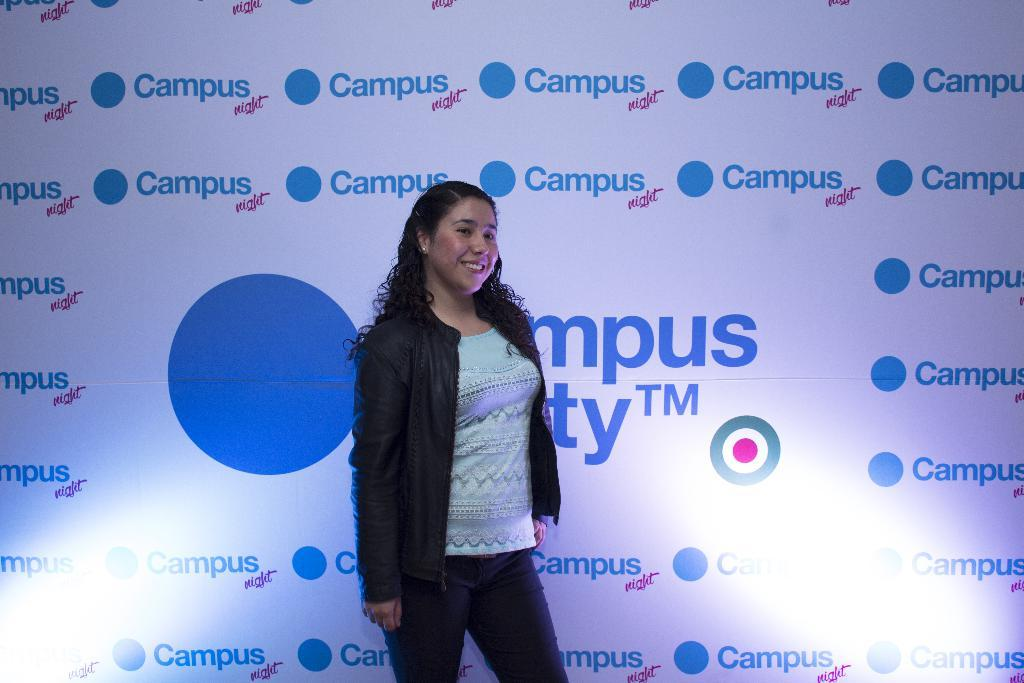Who is the main subject in the image? There is a lady in the image. What is the lady wearing on her upper body? The lady is wearing a black jacket and a blue t-shirt. What is the lady's facial expression in the image? The lady is smiling. What can be seen in the background of the image? There is a banner in the background of the image. Can you see a skate being used by the lady in the image? There is no skate present in the image. Is there a stream visible in the background of the image? There is no stream visible in the image; only a banner is present in the background. 